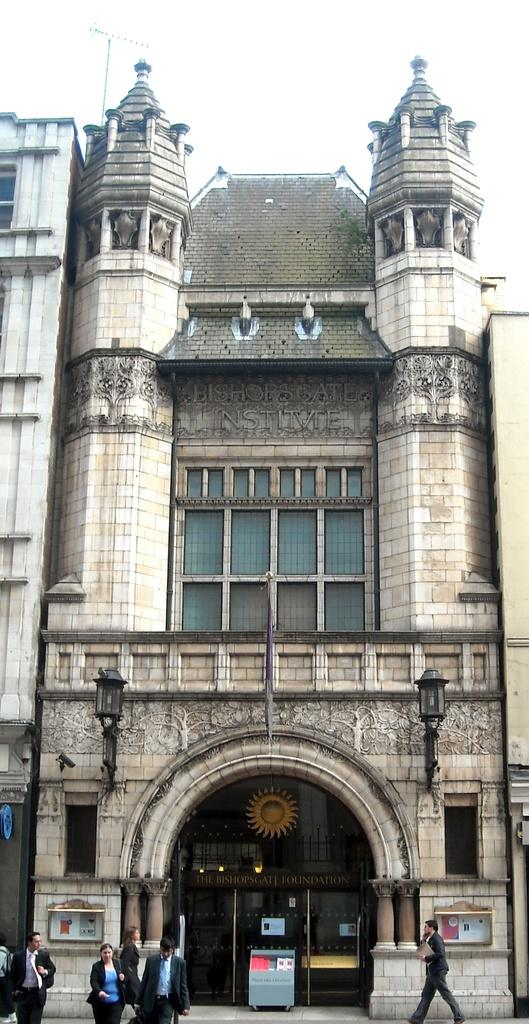What is the main subject in the center of the image? There is a building in the center of the image. What can be seen at the bottom of the image? There are people walking at the bottom of the image. What is visible at the top of the image? The sky is visible at the top of the image. What date is marked on the calendar in the image? There is no calendar present in the image. 